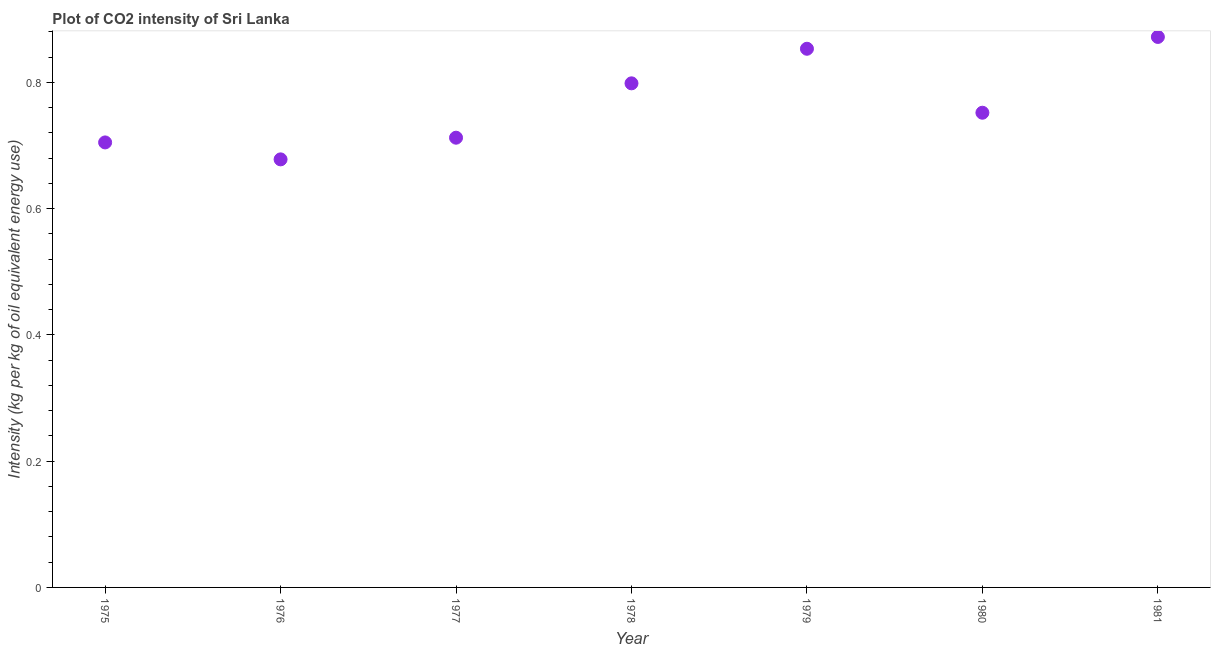What is the co2 intensity in 1978?
Ensure brevity in your answer.  0.8. Across all years, what is the maximum co2 intensity?
Keep it short and to the point. 0.87. Across all years, what is the minimum co2 intensity?
Provide a succinct answer. 0.68. In which year was the co2 intensity minimum?
Your response must be concise. 1976. What is the sum of the co2 intensity?
Provide a succinct answer. 5.37. What is the difference between the co2 intensity in 1978 and 1979?
Your response must be concise. -0.05. What is the average co2 intensity per year?
Offer a very short reply. 0.77. What is the median co2 intensity?
Provide a short and direct response. 0.75. What is the ratio of the co2 intensity in 1978 to that in 1981?
Make the answer very short. 0.92. What is the difference between the highest and the second highest co2 intensity?
Make the answer very short. 0.02. Is the sum of the co2 intensity in 1978 and 1979 greater than the maximum co2 intensity across all years?
Keep it short and to the point. Yes. What is the difference between the highest and the lowest co2 intensity?
Give a very brief answer. 0.19. How many dotlines are there?
Give a very brief answer. 1. Are the values on the major ticks of Y-axis written in scientific E-notation?
Keep it short and to the point. No. Does the graph contain any zero values?
Provide a succinct answer. No. What is the title of the graph?
Give a very brief answer. Plot of CO2 intensity of Sri Lanka. What is the label or title of the X-axis?
Your answer should be compact. Year. What is the label or title of the Y-axis?
Your response must be concise. Intensity (kg per kg of oil equivalent energy use). What is the Intensity (kg per kg of oil equivalent energy use) in 1975?
Give a very brief answer. 0.71. What is the Intensity (kg per kg of oil equivalent energy use) in 1976?
Offer a terse response. 0.68. What is the Intensity (kg per kg of oil equivalent energy use) in 1977?
Offer a terse response. 0.71. What is the Intensity (kg per kg of oil equivalent energy use) in 1978?
Your answer should be compact. 0.8. What is the Intensity (kg per kg of oil equivalent energy use) in 1979?
Make the answer very short. 0.85. What is the Intensity (kg per kg of oil equivalent energy use) in 1980?
Offer a terse response. 0.75. What is the Intensity (kg per kg of oil equivalent energy use) in 1981?
Your answer should be compact. 0.87. What is the difference between the Intensity (kg per kg of oil equivalent energy use) in 1975 and 1976?
Your answer should be compact. 0.03. What is the difference between the Intensity (kg per kg of oil equivalent energy use) in 1975 and 1977?
Offer a very short reply. -0.01. What is the difference between the Intensity (kg per kg of oil equivalent energy use) in 1975 and 1978?
Offer a very short reply. -0.09. What is the difference between the Intensity (kg per kg of oil equivalent energy use) in 1975 and 1979?
Your answer should be very brief. -0.15. What is the difference between the Intensity (kg per kg of oil equivalent energy use) in 1975 and 1980?
Your response must be concise. -0.05. What is the difference between the Intensity (kg per kg of oil equivalent energy use) in 1975 and 1981?
Ensure brevity in your answer.  -0.17. What is the difference between the Intensity (kg per kg of oil equivalent energy use) in 1976 and 1977?
Provide a short and direct response. -0.03. What is the difference between the Intensity (kg per kg of oil equivalent energy use) in 1976 and 1978?
Offer a terse response. -0.12. What is the difference between the Intensity (kg per kg of oil equivalent energy use) in 1976 and 1979?
Provide a short and direct response. -0.18. What is the difference between the Intensity (kg per kg of oil equivalent energy use) in 1976 and 1980?
Keep it short and to the point. -0.07. What is the difference between the Intensity (kg per kg of oil equivalent energy use) in 1976 and 1981?
Make the answer very short. -0.19. What is the difference between the Intensity (kg per kg of oil equivalent energy use) in 1977 and 1978?
Your answer should be compact. -0.09. What is the difference between the Intensity (kg per kg of oil equivalent energy use) in 1977 and 1979?
Provide a short and direct response. -0.14. What is the difference between the Intensity (kg per kg of oil equivalent energy use) in 1977 and 1980?
Ensure brevity in your answer.  -0.04. What is the difference between the Intensity (kg per kg of oil equivalent energy use) in 1977 and 1981?
Your answer should be compact. -0.16. What is the difference between the Intensity (kg per kg of oil equivalent energy use) in 1978 and 1979?
Keep it short and to the point. -0.05. What is the difference between the Intensity (kg per kg of oil equivalent energy use) in 1978 and 1980?
Offer a terse response. 0.05. What is the difference between the Intensity (kg per kg of oil equivalent energy use) in 1978 and 1981?
Offer a very short reply. -0.07. What is the difference between the Intensity (kg per kg of oil equivalent energy use) in 1979 and 1980?
Offer a terse response. 0.1. What is the difference between the Intensity (kg per kg of oil equivalent energy use) in 1979 and 1981?
Make the answer very short. -0.02. What is the difference between the Intensity (kg per kg of oil equivalent energy use) in 1980 and 1981?
Keep it short and to the point. -0.12. What is the ratio of the Intensity (kg per kg of oil equivalent energy use) in 1975 to that in 1976?
Your response must be concise. 1.04. What is the ratio of the Intensity (kg per kg of oil equivalent energy use) in 1975 to that in 1977?
Give a very brief answer. 0.99. What is the ratio of the Intensity (kg per kg of oil equivalent energy use) in 1975 to that in 1978?
Provide a short and direct response. 0.88. What is the ratio of the Intensity (kg per kg of oil equivalent energy use) in 1975 to that in 1979?
Keep it short and to the point. 0.83. What is the ratio of the Intensity (kg per kg of oil equivalent energy use) in 1975 to that in 1980?
Keep it short and to the point. 0.94. What is the ratio of the Intensity (kg per kg of oil equivalent energy use) in 1975 to that in 1981?
Keep it short and to the point. 0.81. What is the ratio of the Intensity (kg per kg of oil equivalent energy use) in 1976 to that in 1977?
Provide a short and direct response. 0.95. What is the ratio of the Intensity (kg per kg of oil equivalent energy use) in 1976 to that in 1978?
Offer a terse response. 0.85. What is the ratio of the Intensity (kg per kg of oil equivalent energy use) in 1976 to that in 1979?
Give a very brief answer. 0.8. What is the ratio of the Intensity (kg per kg of oil equivalent energy use) in 1976 to that in 1980?
Your answer should be compact. 0.9. What is the ratio of the Intensity (kg per kg of oil equivalent energy use) in 1976 to that in 1981?
Offer a very short reply. 0.78. What is the ratio of the Intensity (kg per kg of oil equivalent energy use) in 1977 to that in 1978?
Ensure brevity in your answer.  0.89. What is the ratio of the Intensity (kg per kg of oil equivalent energy use) in 1977 to that in 1979?
Your answer should be very brief. 0.83. What is the ratio of the Intensity (kg per kg of oil equivalent energy use) in 1977 to that in 1980?
Keep it short and to the point. 0.95. What is the ratio of the Intensity (kg per kg of oil equivalent energy use) in 1977 to that in 1981?
Your answer should be compact. 0.82. What is the ratio of the Intensity (kg per kg of oil equivalent energy use) in 1978 to that in 1979?
Keep it short and to the point. 0.94. What is the ratio of the Intensity (kg per kg of oil equivalent energy use) in 1978 to that in 1980?
Your answer should be compact. 1.06. What is the ratio of the Intensity (kg per kg of oil equivalent energy use) in 1978 to that in 1981?
Offer a very short reply. 0.92. What is the ratio of the Intensity (kg per kg of oil equivalent energy use) in 1979 to that in 1980?
Your response must be concise. 1.14. What is the ratio of the Intensity (kg per kg of oil equivalent energy use) in 1979 to that in 1981?
Offer a very short reply. 0.98. What is the ratio of the Intensity (kg per kg of oil equivalent energy use) in 1980 to that in 1981?
Give a very brief answer. 0.86. 